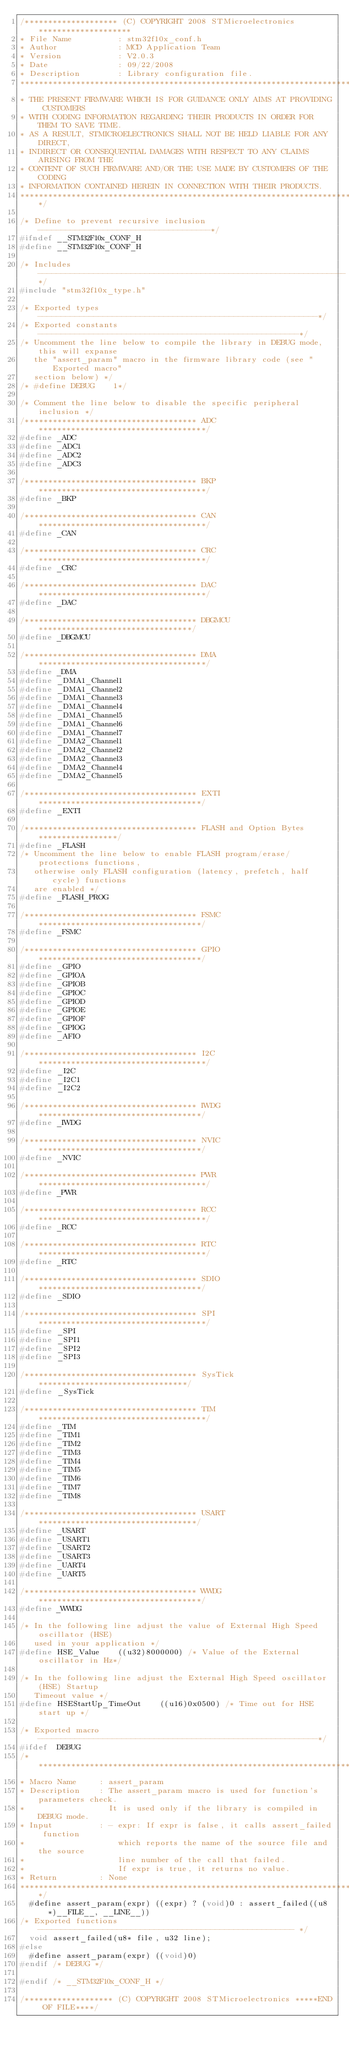Convert code to text. <code><loc_0><loc_0><loc_500><loc_500><_C_>/******************** (C) COPYRIGHT 2008 STMicroelectronics ********************
* File Name          : stm32f10x_conf.h
* Author             : MCD Application Team
* Version            : V2.0.3
* Date               : 09/22/2008
* Description        : Library configuration file.
********************************************************************************
* THE PRESENT FIRMWARE WHICH IS FOR GUIDANCE ONLY AIMS AT PROVIDING CUSTOMERS
* WITH CODING INFORMATION REGARDING THEIR PRODUCTS IN ORDER FOR THEM TO SAVE TIME.
* AS A RESULT, STMICROELECTRONICS SHALL NOT BE HELD LIABLE FOR ANY DIRECT,
* INDIRECT OR CONSEQUENTIAL DAMAGES WITH RESPECT TO ANY CLAIMS ARISING FROM THE
* CONTENT OF SUCH FIRMWARE AND/OR THE USE MADE BY CUSTOMERS OF THE CODING
* INFORMATION CONTAINED HEREIN IN CONNECTION WITH THEIR PRODUCTS.
*******************************************************************************/

/* Define to prevent recursive inclusion -------------------------------------*/
#ifndef __STM32F10x_CONF_H
#define __STM32F10x_CONF_H

/* Includes ------------------------------------------------------------------*/
#include "stm32f10x_type.h"

/* Exported types ------------------------------------------------------------*/
/* Exported constants --------------------------------------------------------*/
/* Uncomment the line below to compile the library in DEBUG mode, this will expanse
   the "assert_param" macro in the firmware library code (see "Exported macro"
   section below) */
/* #define DEBUG    1*/

/* Comment the line below to disable the specific peripheral inclusion */
/************************************* ADC ************************************/
#define _ADC
#define _ADC1
#define _ADC2
#define _ADC3

/************************************* BKP ************************************/
#define _BKP 

/************************************* CAN ************************************/
#define _CAN

/************************************* CRC ************************************/
#define _CRC

/************************************* DAC ************************************/
#define _DAC

/************************************* DBGMCU *********************************/
#define _DBGMCU

/************************************* DMA ************************************/
#define _DMA
#define _DMA1_Channel1
#define _DMA1_Channel2
#define _DMA1_Channel3
#define _DMA1_Channel4
#define _DMA1_Channel5
#define _DMA1_Channel6
#define _DMA1_Channel7
#define _DMA2_Channel1
#define _DMA2_Channel2
#define _DMA2_Channel3
#define _DMA2_Channel4
#define _DMA2_Channel5

/************************************* EXTI ***********************************/
#define _EXTI

/************************************* FLASH and Option Bytes *****************/
#define _FLASH
/* Uncomment the line below to enable FLASH program/erase/protections functions,
   otherwise only FLASH configuration (latency, prefetch, half cycle) functions
   are enabled */
#define _FLASH_PROG 

/************************************* FSMC ***********************************/
#define _FSMC

/************************************* GPIO ***********************************/
#define _GPIO
#define _GPIOA
#define _GPIOB
#define _GPIOC
#define _GPIOD
#define _GPIOE
#define _GPIOF
#define _GPIOG
#define _AFIO

/************************************* I2C ************************************/
#define _I2C
#define _I2C1
#define _I2C2

/************************************* IWDG ***********************************/
#define _IWDG

/************************************* NVIC ***********************************/
#define _NVIC

/************************************* PWR ************************************/
#define _PWR

/************************************* RCC ************************************/
#define _RCC

/************************************* RTC ************************************/
#define _RTC

/************************************* SDIO ***********************************/
#define _SDIO

/************************************* SPI ************************************/
#define _SPI
#define _SPI1
#define _SPI2
#define _SPI3

/************************************* SysTick ********************************/
#define _SysTick

/************************************* TIM ************************************/
#define _TIM
#define _TIM1
#define _TIM2
#define _TIM3
#define _TIM4
#define _TIM5
#define _TIM6
#define _TIM7
#define _TIM8

/************************************* USART **********************************/
#define _USART
#define _USART1
#define _USART2
#define _USART3
#define _UART4
#define _UART5

/************************************* WWDG ***********************************/
#define _WWDG

/* In the following line adjust the value of External High Speed oscillator (HSE)
   used in your application */
#define HSE_Value    ((u32)8000000) /* Value of the External oscillator in Hz*/

/* In the following line adjust the External High Speed oscillator (HSE) Startup 
   Timeout value */
#define HSEStartUp_TimeOut    ((u16)0x0500) /* Time out for HSE start up */

/* Exported macro ------------------------------------------------------------*/
#ifdef  DEBUG
/*******************************************************************************
* Macro Name     : assert_param
* Description    : The assert_param macro is used for function's parameters check.
*                  It is used only if the library is compiled in DEBUG mode. 
* Input          : - expr: If expr is false, it calls assert_failed function
*                    which reports the name of the source file and the source
*                    line number of the call that failed. 
*                    If expr is true, it returns no value.
* Return         : None
*******************************************************************************/ 
  #define assert_param(expr) ((expr) ? (void)0 : assert_failed((u8 *)__FILE__, __LINE__))
/* Exported functions ------------------------------------------------------- */
  void assert_failed(u8* file, u32 line);
#else
  #define assert_param(expr) ((void)0)
#endif /* DEBUG */

#endif /* __STM32F10x_CONF_H */

/******************* (C) COPYRIGHT 2008 STMicroelectronics *****END OF FILE****/
</code> 